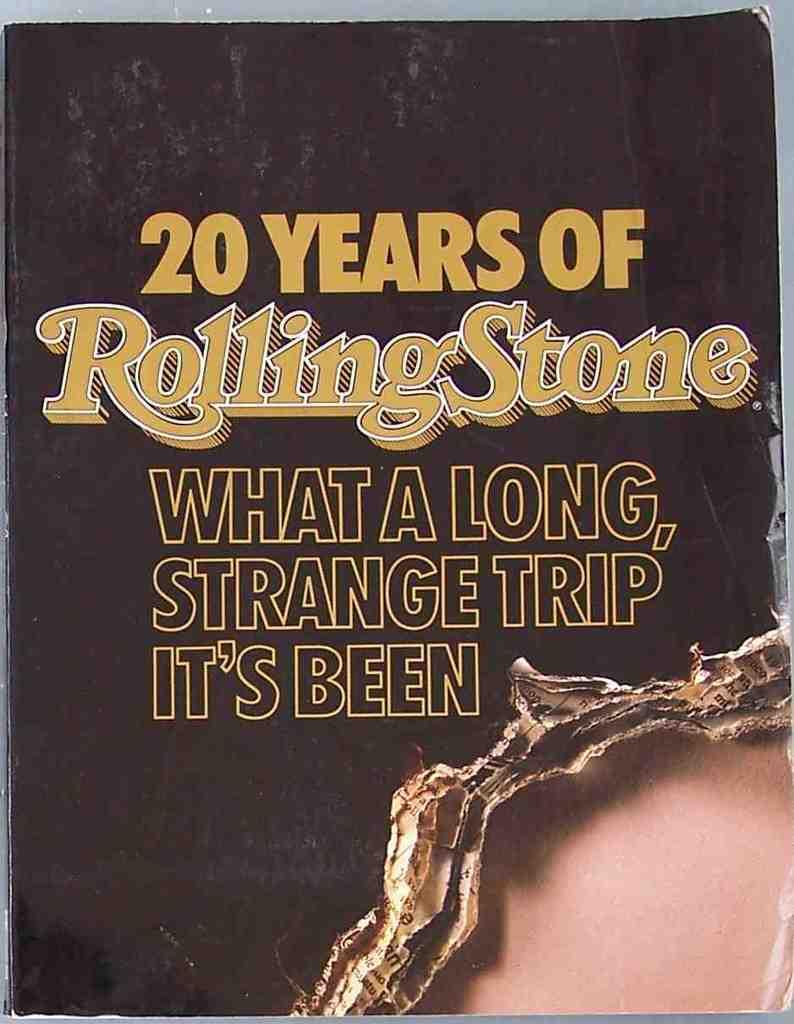How long has the rolling stone been around?
Make the answer very short. 20 years. Which magazine company is this?
Your response must be concise. Rolling stone. 